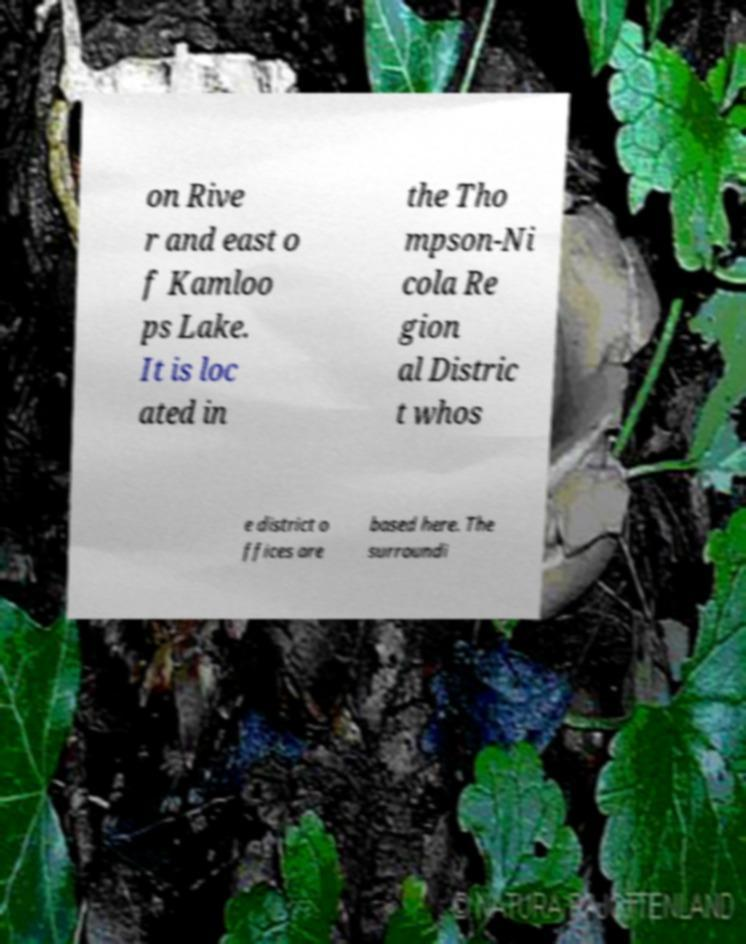Please identify and transcribe the text found in this image. on Rive r and east o f Kamloo ps Lake. It is loc ated in the Tho mpson-Ni cola Re gion al Distric t whos e district o ffices are based here. The surroundi 